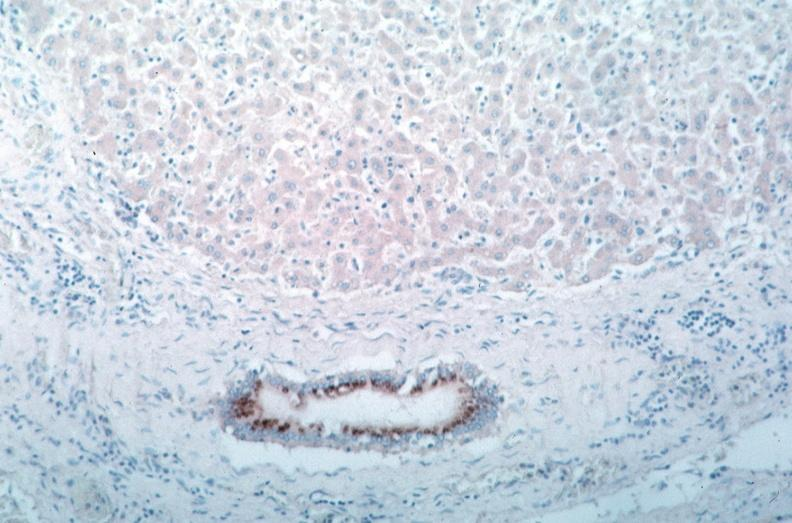does natural color show vasculitis?
Answer the question using a single word or phrase. No 